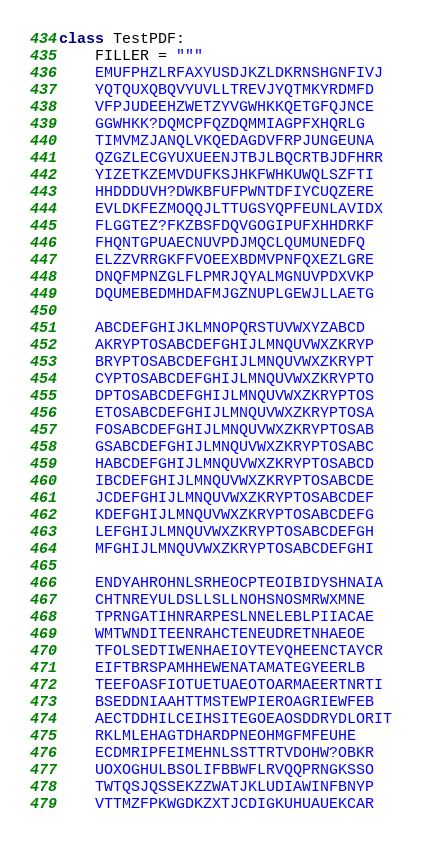Convert code to text. <code><loc_0><loc_0><loc_500><loc_500><_Python_>class TestPDF:
    FILLER = """
    EMUFPHZLRFAXYUSDJKZLDKRNSHGNFIVJ
    YQTQUXQBQVYUVLLTREVJYQTMKYRDMFD
    VFPJUDEEHZWETZYVGWHKKQETGFQJNCE
    GGWHKK?DQMCPFQZDQMMIAGPFXHQRLG
    TIMVMZJANQLVKQEDAGDVFRPJUNGEUNA
    QZGZLECGYUXUEENJTBJLBQCRTBJDFHRR
    YIZETKZEMVDUFKSJHKFWHKUWQLSZFTI
    HHDDDUVH?DWKBFUFPWNTDFIYCUQZERE
    EVLDKFEZMOQQJLTTUGSYQPFEUNLAVIDX
    FLGGTEZ?FKZBSFDQVGOGIPUFXHHDRKF
    FHQNTGPUAECNUVPDJMQCLQUMUNEDFQ
    ELZZVRRGKFFVOEEXBDMVPNFQXEZLGRE
    DNQFMPNZGLFLPMRJQYALMGNUVPDXVKP
    DQUMEBEDMHDAFMJGZNUPLGEWJLLAETG

    ABCDEFGHIJKLMNOPQRSTUVWXYZABCD
    AKRYPTOSABCDEFGHIJLMNQUVWXZKRYP
    BRYPTOSABCDEFGHIJLMNQUVWXZKRYPT
    CYPTOSABCDEFGHIJLMNQUVWXZKRYPTO
    DPTOSABCDEFGHIJLMNQUVWXZKRYPTOS
    ETOSABCDEFGHIJLMNQUVWXZKRYPTOSA
    FOSABCDEFGHIJLMNQUVWXZKRYPTOSAB
    GSABCDEFGHIJLMNQUVWXZKRYPTOSABC
    HABCDEFGHIJLMNQUVWXZKRYPTOSABCD
    IBCDEFGHIJLMNQUVWXZKRYPTOSABCDE
    JCDEFGHIJLMNQUVWXZKRYPTOSABCDEF
    KDEFGHIJLMNQUVWXZKRYPTOSABCDEFG
    LEFGHIJLMNQUVWXZKRYPTOSABCDEFGH
    MFGHIJLMNQUVWXZKRYPTOSABCDEFGHI

    ENDYAHROHNLSRHEOCPTEOIBIDYSHNAIA
    CHTNREYULDSLLSLLNOHSNOSMRWXMNE
    TPRNGATIHNRARPESLNNELEBLPIIACAE
    WMTWNDITEENRAHCTENEUDRETNHAEOE
    TFOLSEDTIWENHAEIOYTEYQHEENCTAYCR
    EIFTBRSPAMHHEWENATAMATEGYEERLB
    TEEFOASFIOTUETUAEOTOARMAEERTNRTI
    BSEDDNIAAHTTMSTEWPIEROAGRIEWFEB
    AECTDDHILCEIHSITEGOEAOSDDRYDLORIT
    RKLMLEHAGTDHARDPNEOHMGFMFEUHE
    ECDMRIPFEIMEHNLSSTTRTVDOHW?OBKR
    UOXOGHULBSOLIFBBWFLRVQQPRNGKSSO
    TWTQSJQSSEKZZWATJKLUDIAWINFBNYP
    VTTMZFPKWGDKZXTJCDIGKUHUAUEKCAR
</code> 